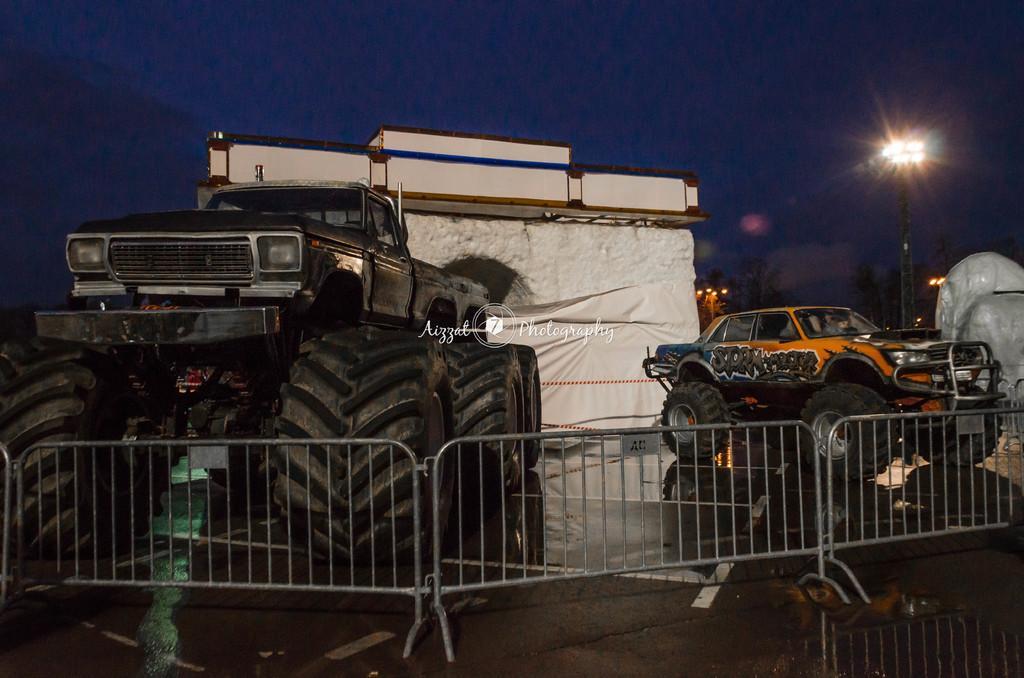How would you summarize this image in a sentence or two? In this image, we can see vehicles, lights and a railing are present. 